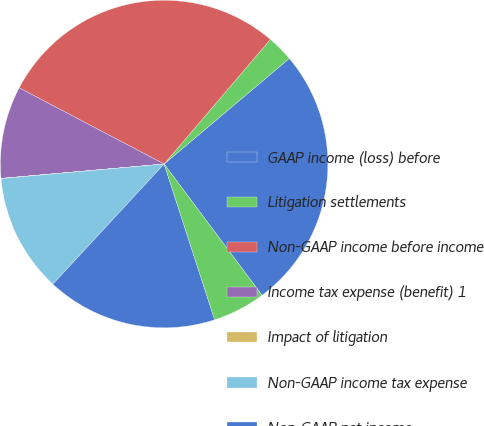Convert chart to OTSL. <chart><loc_0><loc_0><loc_500><loc_500><pie_chart><fcel>GAAP income (loss) before<fcel>Litigation settlements<fcel>Non-GAAP income before income<fcel>Income tax expense (benefit) 1<fcel>Impact of litigation<fcel>Non-GAAP income tax expense<fcel>Non-GAAP net income<fcel>Non-GAAP effective tax rate<nl><fcel>25.95%<fcel>2.61%<fcel>28.54%<fcel>9.1%<fcel>0.02%<fcel>11.7%<fcel>16.88%<fcel>5.21%<nl></chart> 